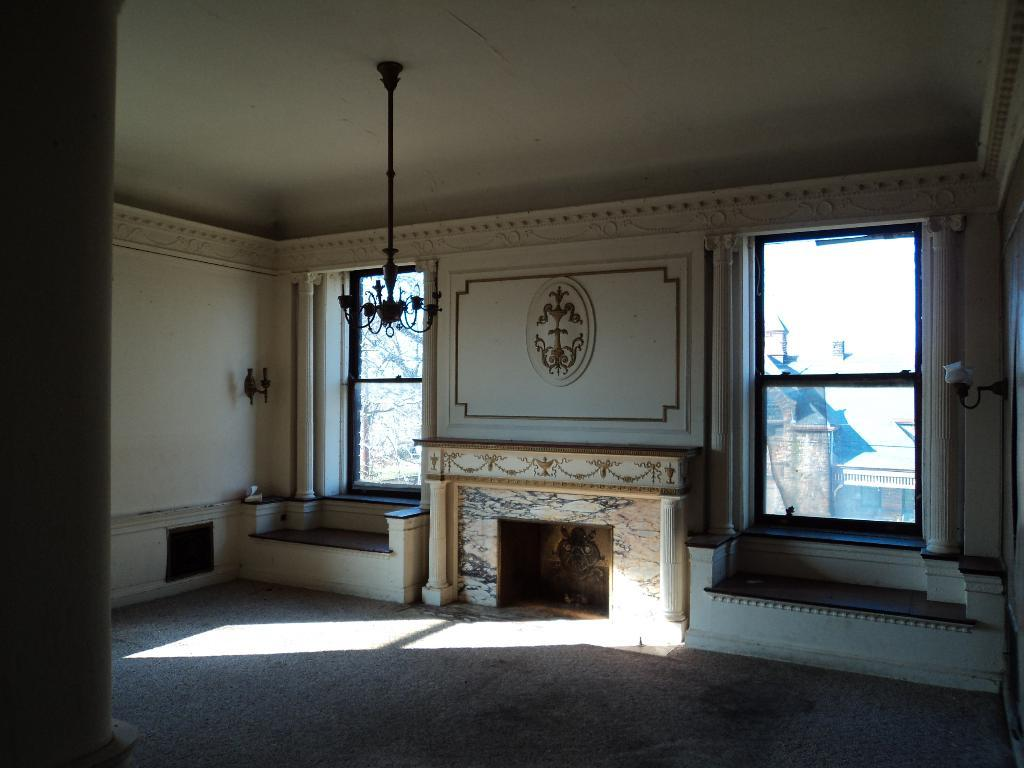Where is the setting of the image? The image is inside a room. What feature can be found in the room? There is a fireplace in the room. Can you describe the wall design in the room? The room has a wall design. What type of lighting is present in the room? There is a lamp and a chandelier in the room. What can be seen through the windows in the room? Buildings and trees are visible through the windows. What is the opinion of the furniture in the room? There is no furniture present in the image, so it is not possible to determine its opinion. 